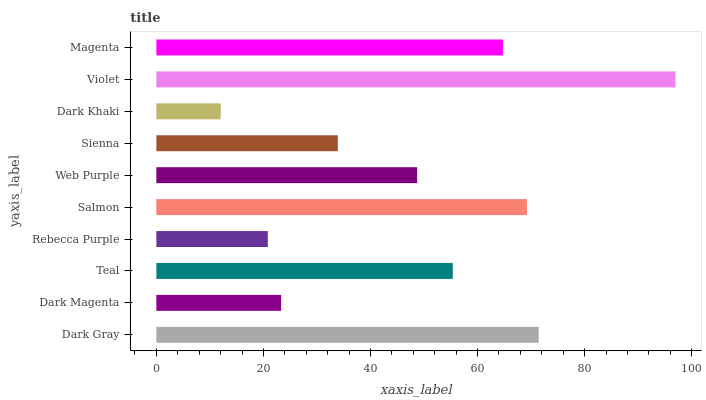Is Dark Khaki the minimum?
Answer yes or no. Yes. Is Violet the maximum?
Answer yes or no. Yes. Is Dark Magenta the minimum?
Answer yes or no. No. Is Dark Magenta the maximum?
Answer yes or no. No. Is Dark Gray greater than Dark Magenta?
Answer yes or no. Yes. Is Dark Magenta less than Dark Gray?
Answer yes or no. Yes. Is Dark Magenta greater than Dark Gray?
Answer yes or no. No. Is Dark Gray less than Dark Magenta?
Answer yes or no. No. Is Teal the high median?
Answer yes or no. Yes. Is Web Purple the low median?
Answer yes or no. Yes. Is Dark Magenta the high median?
Answer yes or no. No. Is Violet the low median?
Answer yes or no. No. 